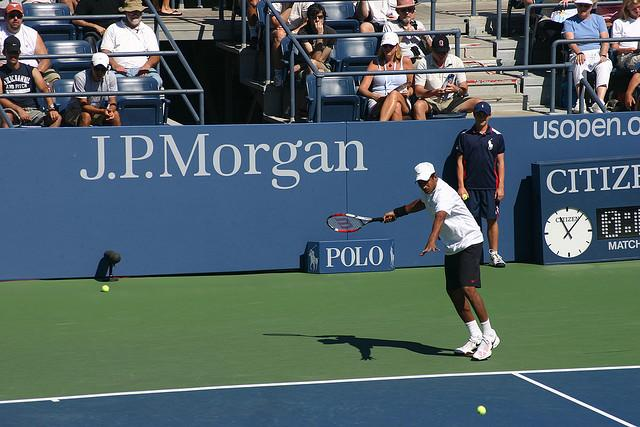What is the finance company advertised on the wall next to the tennis player?

Choices:
A) jp morgan
B) etrade
C) wells fargo
D) ameritrade jp morgan 